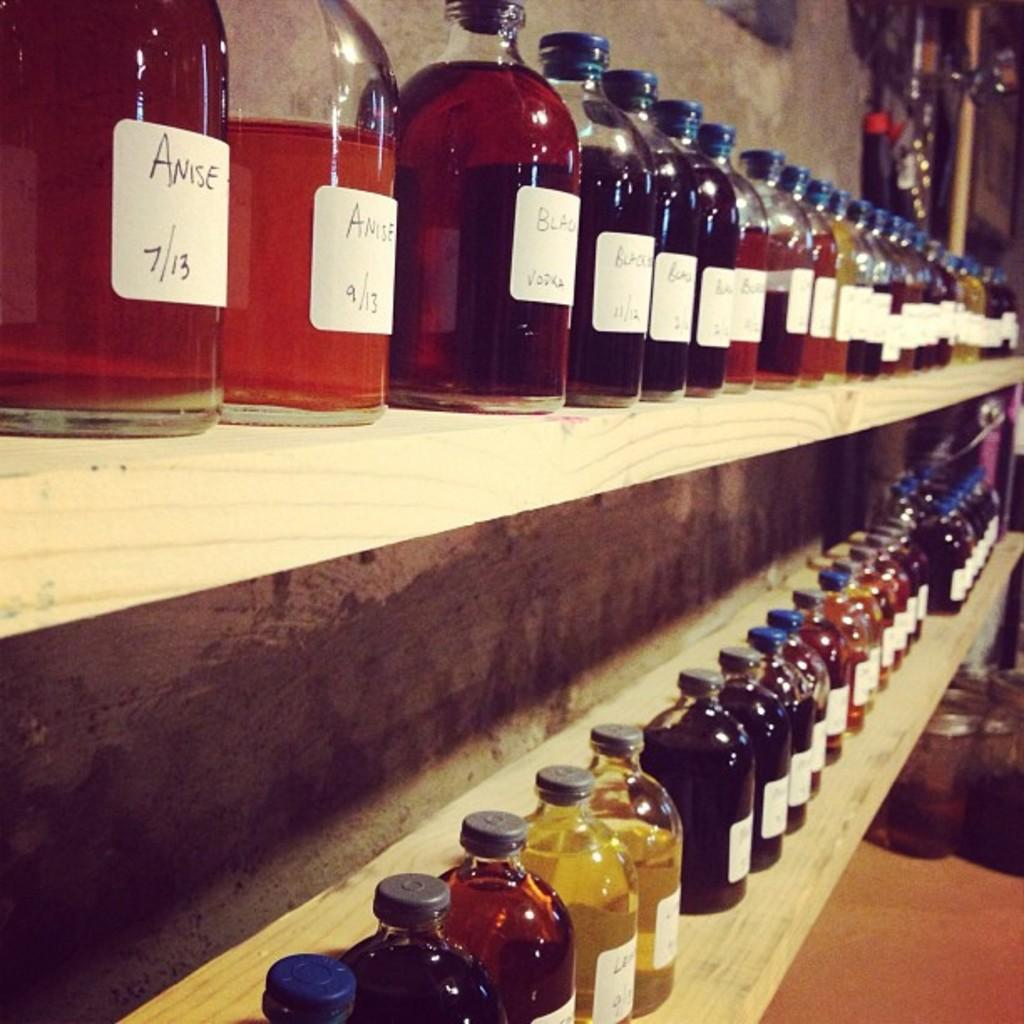<image>
Write a terse but informative summary of the picture. Rows of bottles including one with labels that says Anise 7/13. 